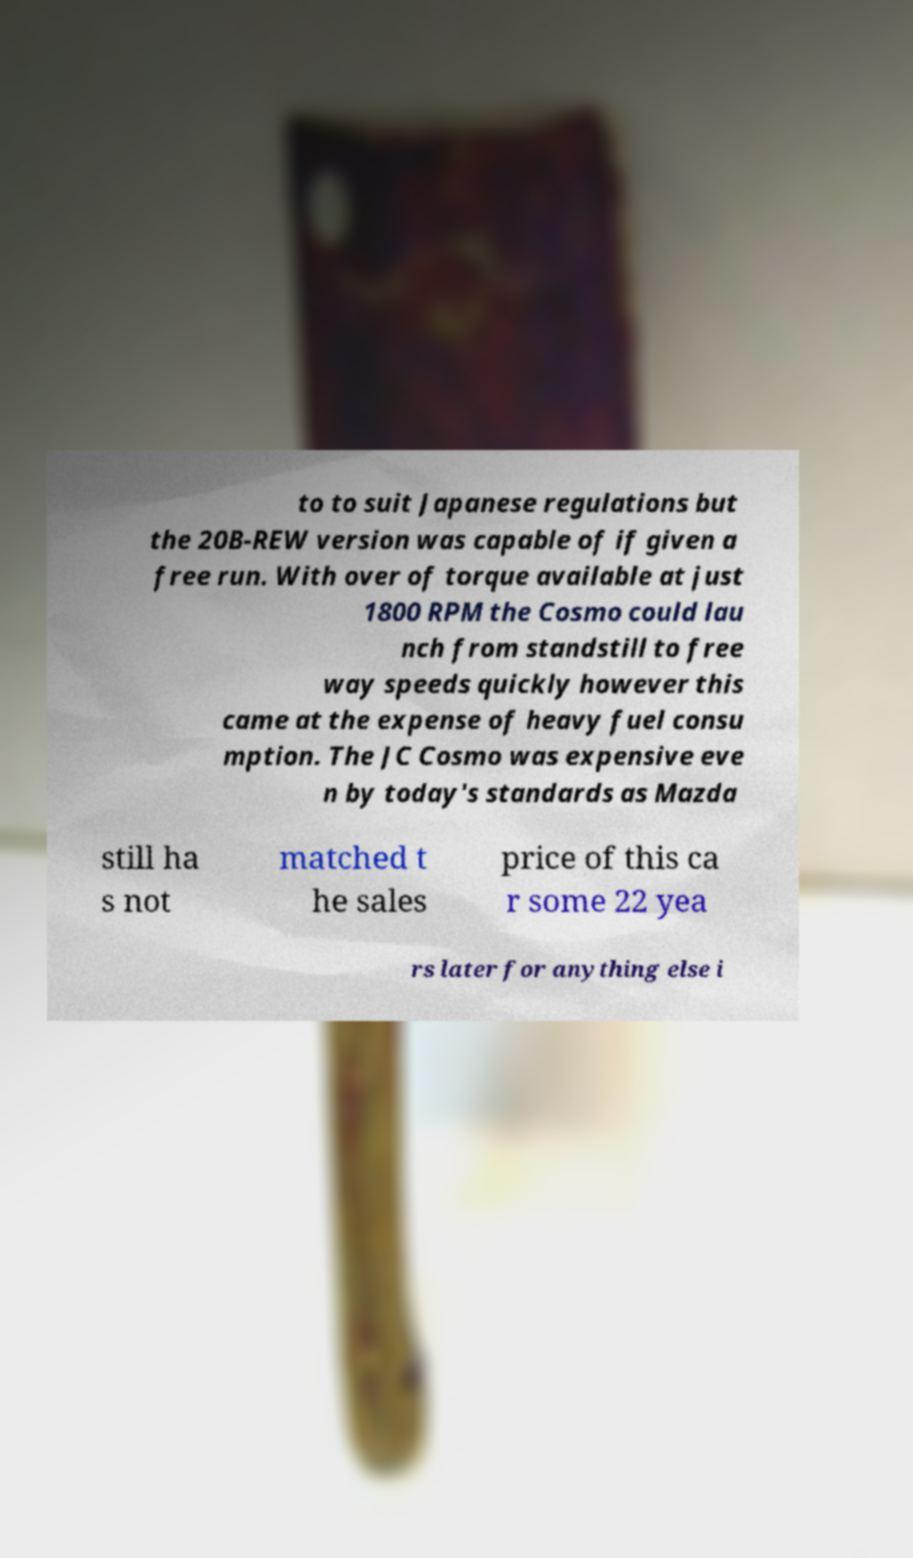Could you extract and type out the text from this image? to to suit Japanese regulations but the 20B-REW version was capable of if given a free run. With over of torque available at just 1800 RPM the Cosmo could lau nch from standstill to free way speeds quickly however this came at the expense of heavy fuel consu mption. The JC Cosmo was expensive eve n by today's standards as Mazda still ha s not matched t he sales price of this ca r some 22 yea rs later for anything else i 